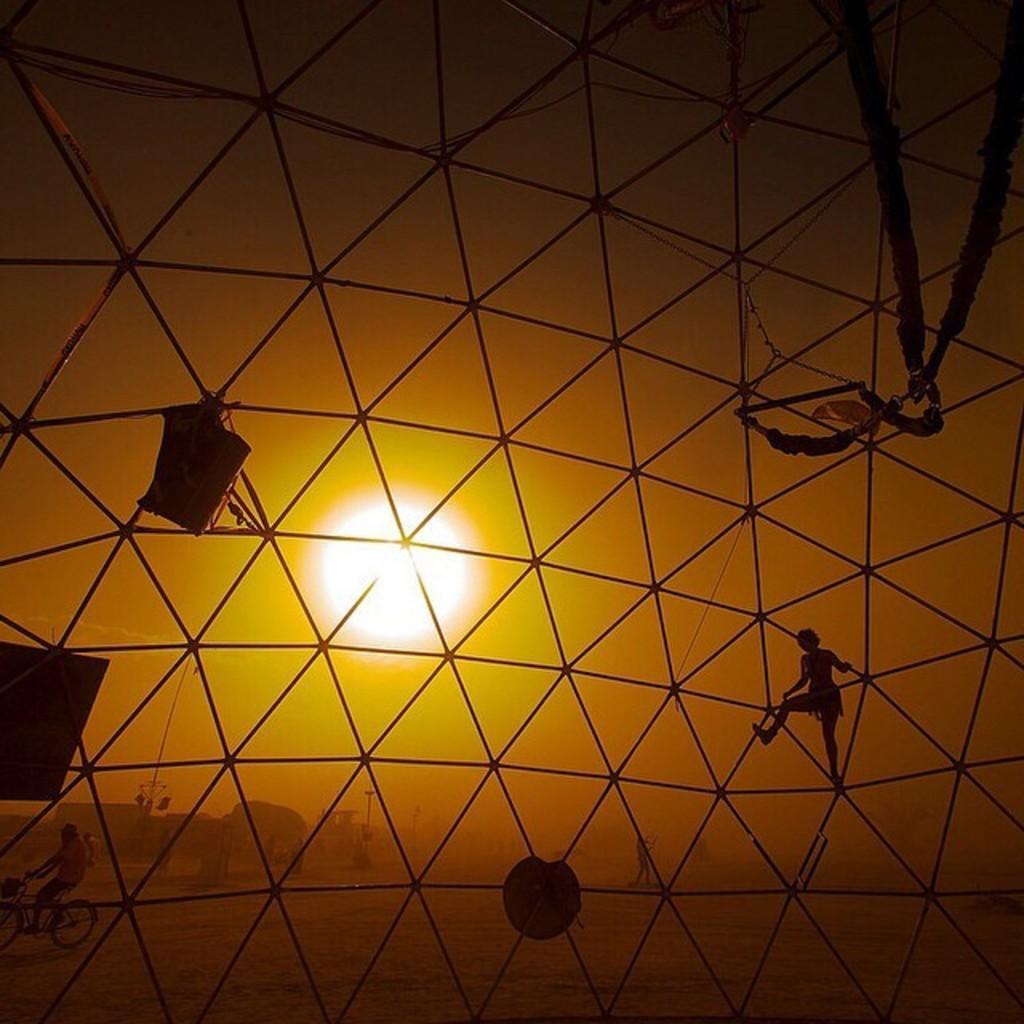How would you summarize this image in a sentence or two? In this image we can see there is a mesh. Through the mesh we can see people and objects. There is sun. 